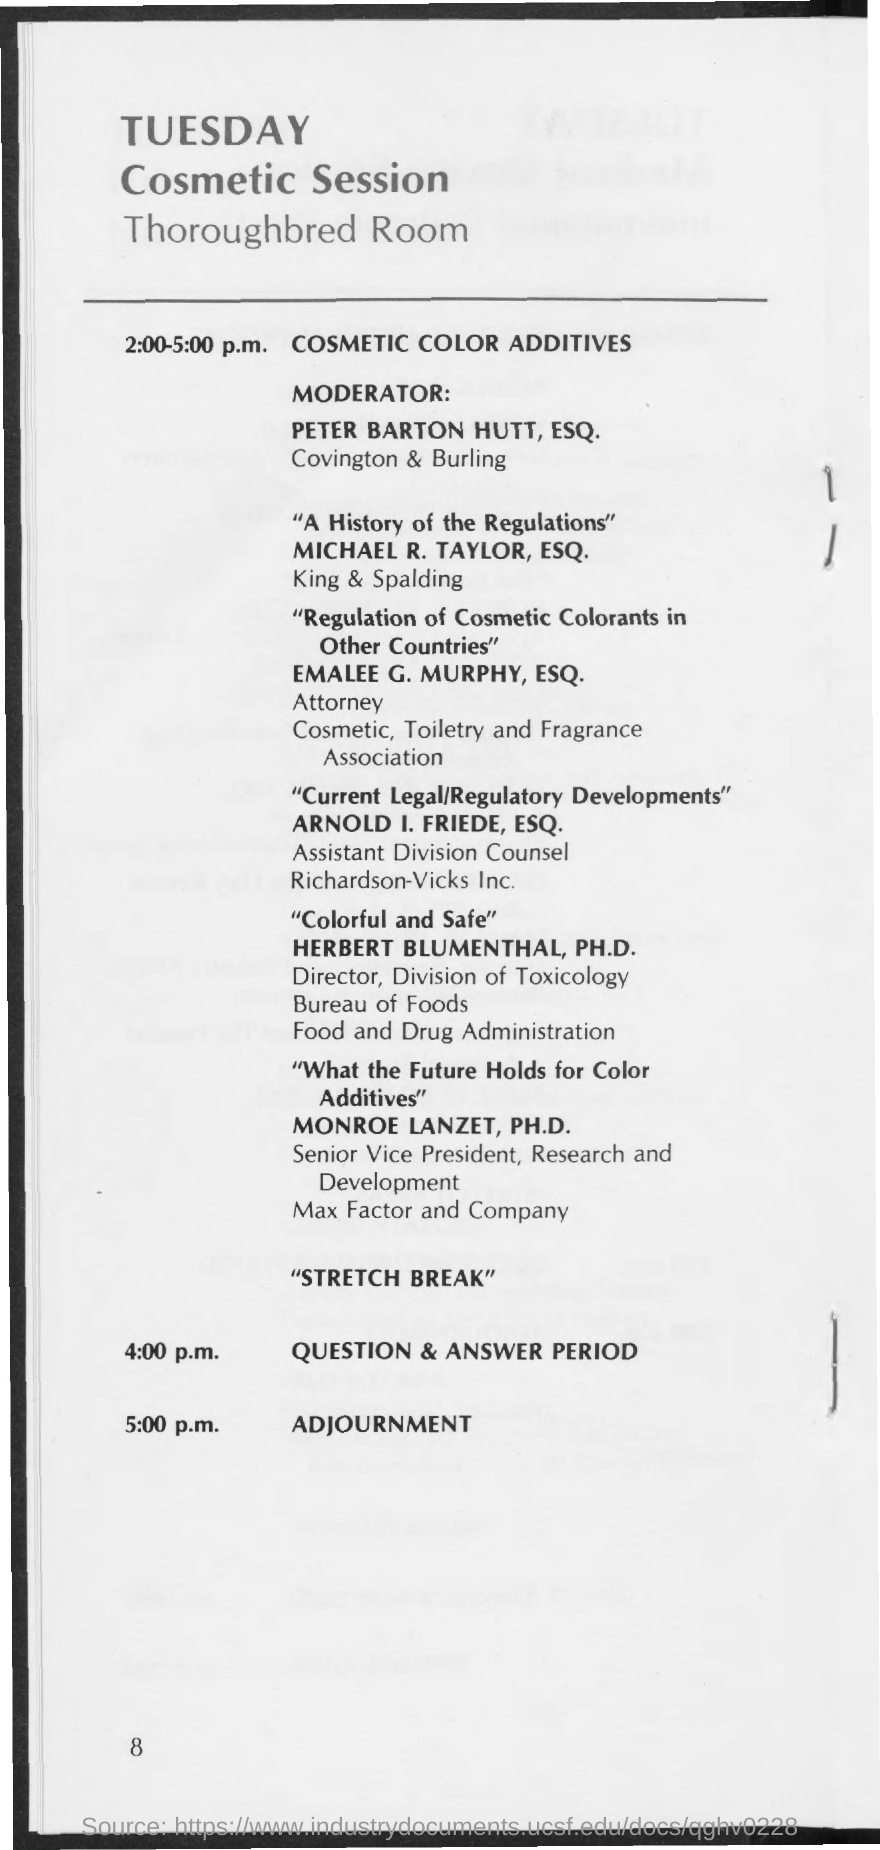Highlight a few significant elements in this photo. The Cosmetic Session is scheduled for Tuesday. The cosmetic session is scheduled to take place in the Thoroughbred Room. The moderator of the Cosmetic Session is Peter Barton Hutt, Esq. 